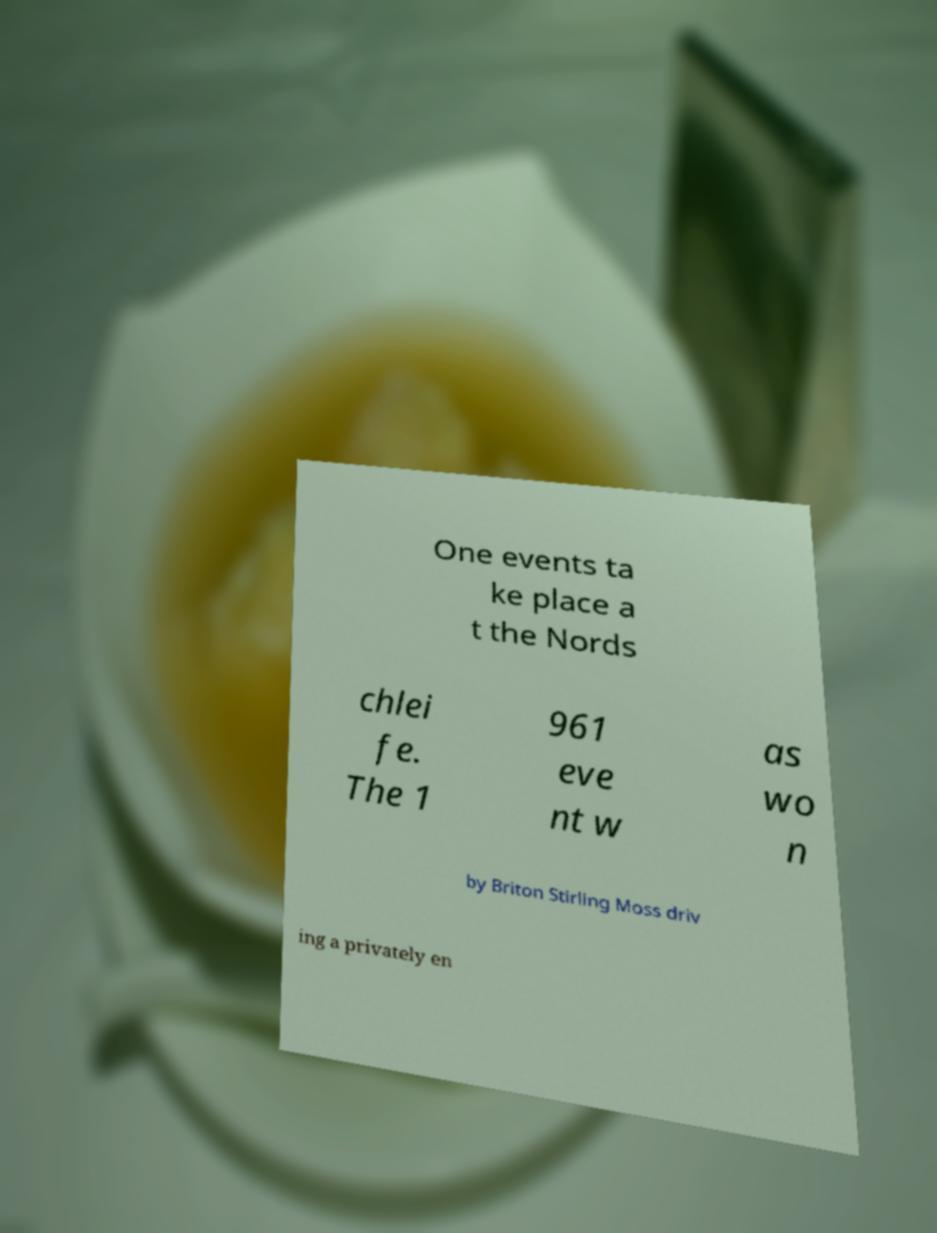For documentation purposes, I need the text within this image transcribed. Could you provide that? One events ta ke place a t the Nords chlei fe. The 1 961 eve nt w as wo n by Briton Stirling Moss driv ing a privately en 